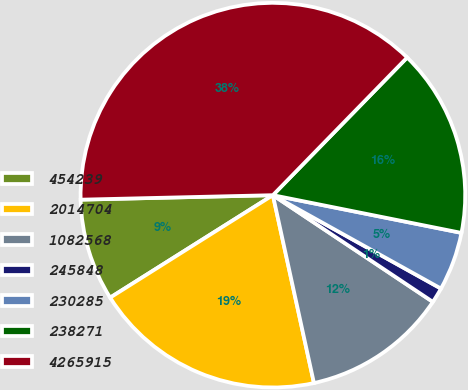Convert chart. <chart><loc_0><loc_0><loc_500><loc_500><pie_chart><fcel>454239<fcel>2014704<fcel>1082568<fcel>245848<fcel>230285<fcel>238271<fcel>4265915<nl><fcel>8.57%<fcel>19.48%<fcel>12.21%<fcel>1.29%<fcel>4.93%<fcel>15.84%<fcel>37.67%<nl></chart> 